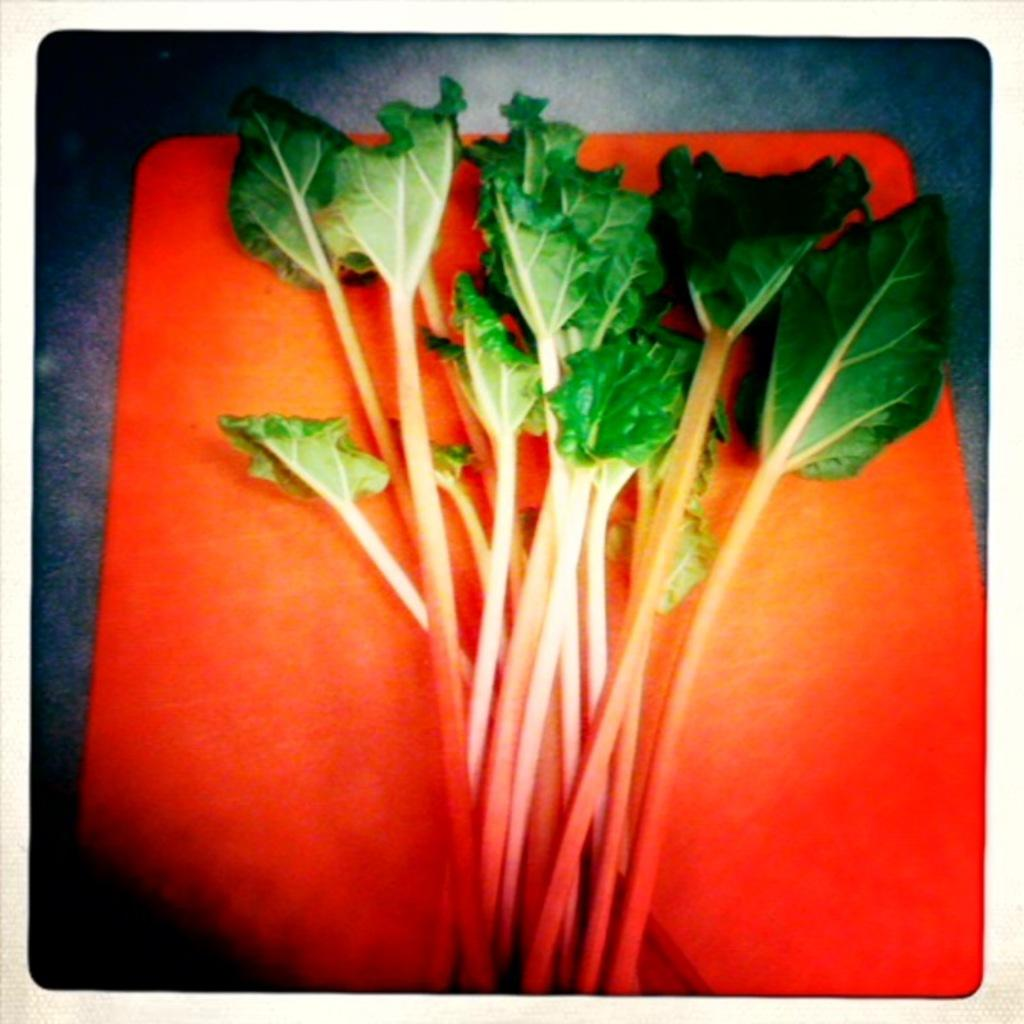What type of vegetation is present in the image? There are green leaves in the image. What is the color of the object on which the green leaves are placed? The green leaves are on an orange object. What type of shoes can be seen in the image? There are no shoes present in the image; it only features green leaves on an orange object. 